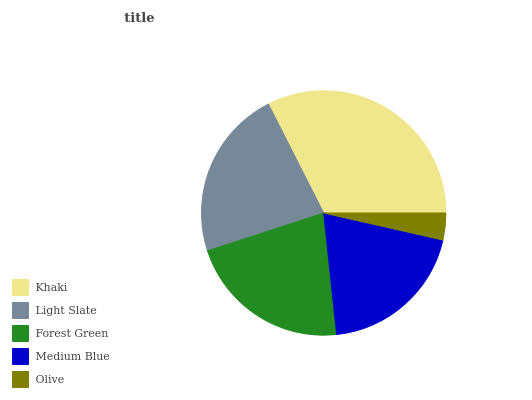Is Olive the minimum?
Answer yes or no. Yes. Is Khaki the maximum?
Answer yes or no. Yes. Is Light Slate the minimum?
Answer yes or no. No. Is Light Slate the maximum?
Answer yes or no. No. Is Khaki greater than Light Slate?
Answer yes or no. Yes. Is Light Slate less than Khaki?
Answer yes or no. Yes. Is Light Slate greater than Khaki?
Answer yes or no. No. Is Khaki less than Light Slate?
Answer yes or no. No. Is Forest Green the high median?
Answer yes or no. Yes. Is Forest Green the low median?
Answer yes or no. Yes. Is Olive the high median?
Answer yes or no. No. Is Medium Blue the low median?
Answer yes or no. No. 